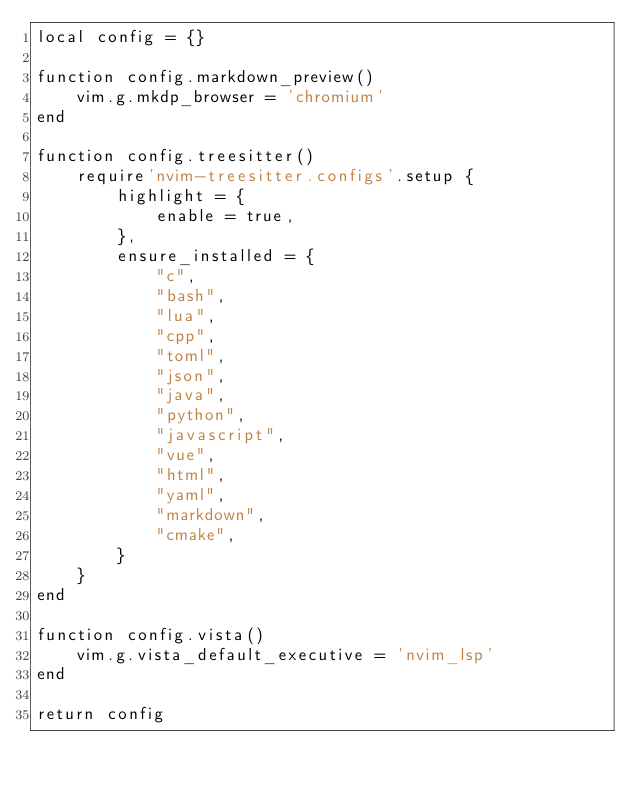Convert code to text. <code><loc_0><loc_0><loc_500><loc_500><_Lua_>local config = {}

function config.markdown_preview()
    vim.g.mkdp_browser = 'chromium'
end

function config.treesitter()
    require'nvim-treesitter.configs'.setup {
        highlight = {
            enable = true,
        },
        ensure_installed = {
            "c",
            "bash",
            "lua",
            "cpp",
            "toml",
            "json",
            "java",
            "python",
            "javascript",
            "vue",
            "html",
            "yaml",
            "markdown",
            "cmake",
        }
    }
end

function config.vista()
    vim.g.vista_default_executive = 'nvim_lsp'
end

return config
</code> 